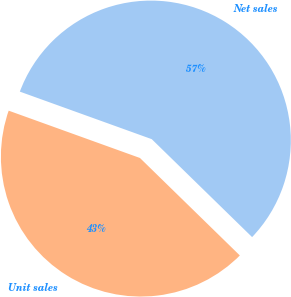Convert chart to OTSL. <chart><loc_0><loc_0><loc_500><loc_500><pie_chart><fcel>Net sales<fcel>Unit sales<nl><fcel>56.8%<fcel>43.2%<nl></chart> 